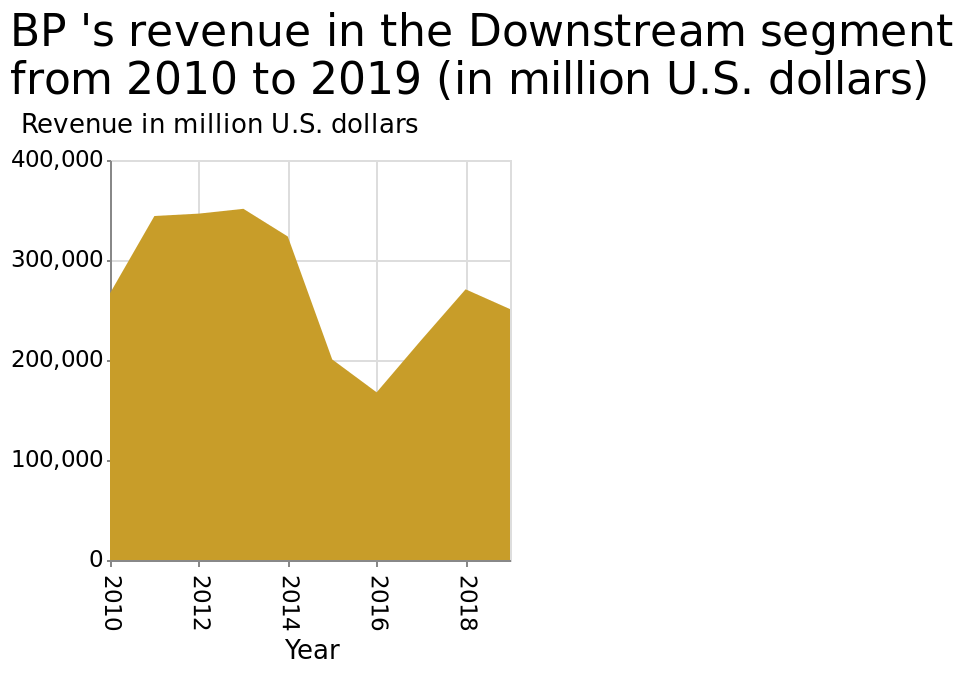<image>
What is the title of the area diagram? The area diagram is titled "BP's revenue in the Downstream segment from 2010 to 2019 (in million U.S. dollars)." What was the trend in BP's revenue from 2011 to 2018?  BP's revenue saw stagnation from 2011 to 2013, followed by a significant drop from 350,000 to 150,000 by 2016. It then rose to 250,000 in 2018. please summary the statistics and relations of the chart BP saw a slight stagnation in 2011 to 2013 which then saw a drop in revenue significantly, dropping from 350,000 to 150,000 ending in 2016. The figures then rose to 250,000 in 2018. Since hen the numbers have begun to decline again and continue to do so. What company does the revenue in the Downstream segment represent? The revenue in the Downstream segment represents BP. 